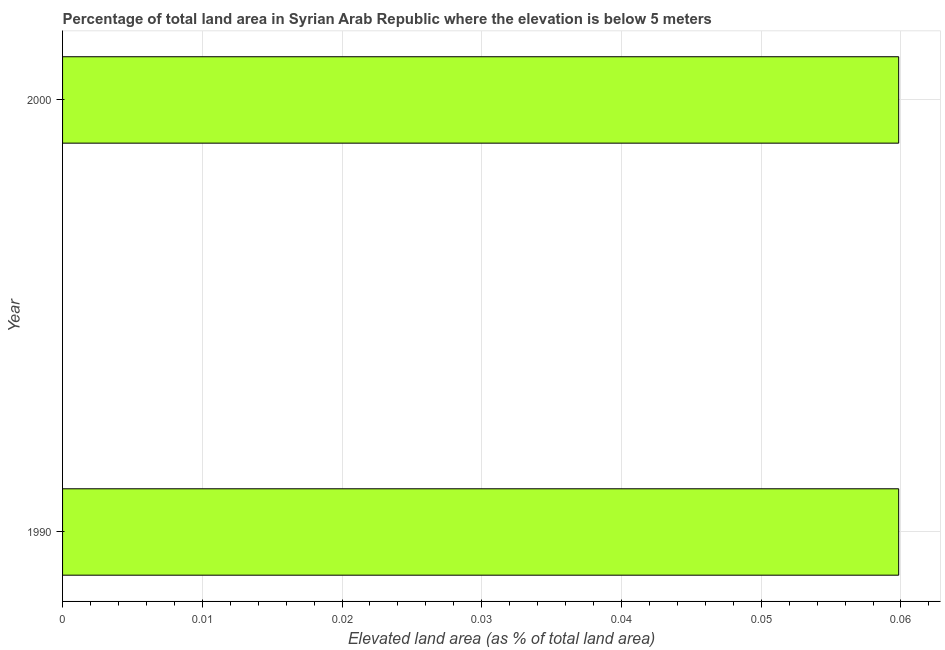Does the graph contain any zero values?
Provide a succinct answer. No. Does the graph contain grids?
Make the answer very short. Yes. What is the title of the graph?
Offer a terse response. Percentage of total land area in Syrian Arab Republic where the elevation is below 5 meters. What is the label or title of the X-axis?
Give a very brief answer. Elevated land area (as % of total land area). What is the label or title of the Y-axis?
Your response must be concise. Year. What is the total elevated land area in 1990?
Provide a short and direct response. 0.06. Across all years, what is the maximum total elevated land area?
Your response must be concise. 0.06. Across all years, what is the minimum total elevated land area?
Offer a terse response. 0.06. In which year was the total elevated land area maximum?
Your answer should be very brief. 1990. In which year was the total elevated land area minimum?
Your response must be concise. 1990. What is the sum of the total elevated land area?
Give a very brief answer. 0.12. What is the average total elevated land area per year?
Your response must be concise. 0.06. What is the median total elevated land area?
Offer a very short reply. 0.06. In how many years, is the total elevated land area greater than 0.056 %?
Your answer should be very brief. 2. What is the ratio of the total elevated land area in 1990 to that in 2000?
Your answer should be compact. 1. In how many years, is the total elevated land area greater than the average total elevated land area taken over all years?
Ensure brevity in your answer.  0. How many bars are there?
Offer a very short reply. 2. How many years are there in the graph?
Give a very brief answer. 2. Are the values on the major ticks of X-axis written in scientific E-notation?
Keep it short and to the point. No. What is the Elevated land area (as % of total land area) of 1990?
Provide a short and direct response. 0.06. What is the Elevated land area (as % of total land area) of 2000?
Give a very brief answer. 0.06. 